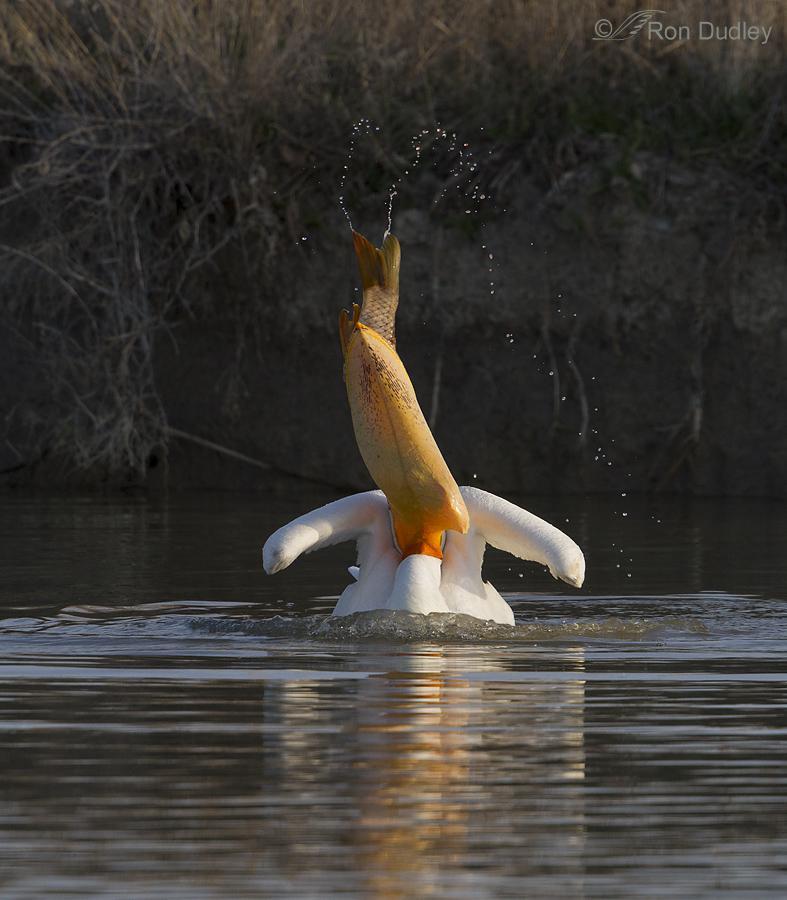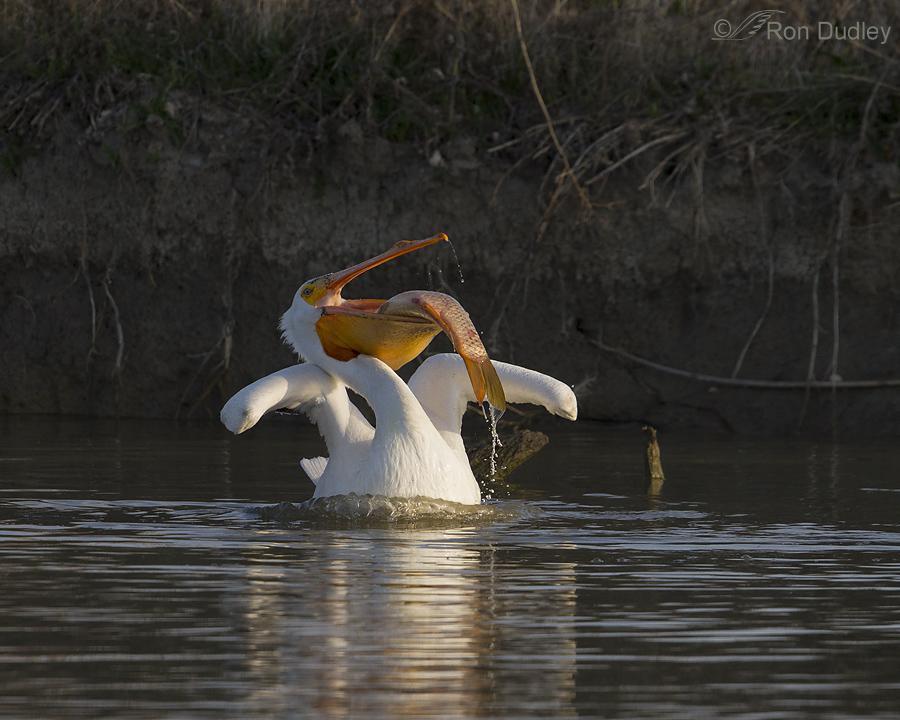The first image is the image on the left, the second image is the image on the right. Analyze the images presented: Is the assertion "An image shows a left-facing dark pelican that has a fish in its bill." valid? Answer yes or no. No. 